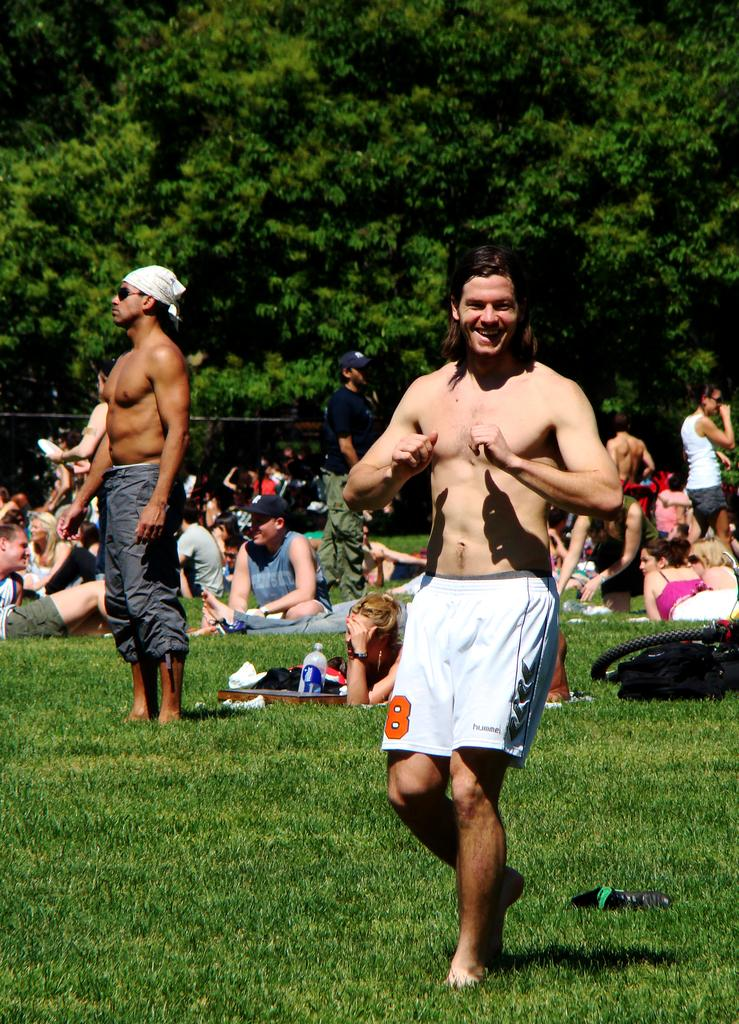Provide a one-sentence caption for the provided image. a man in a crowded park with no shirt on and shorts with number 8 on them. 